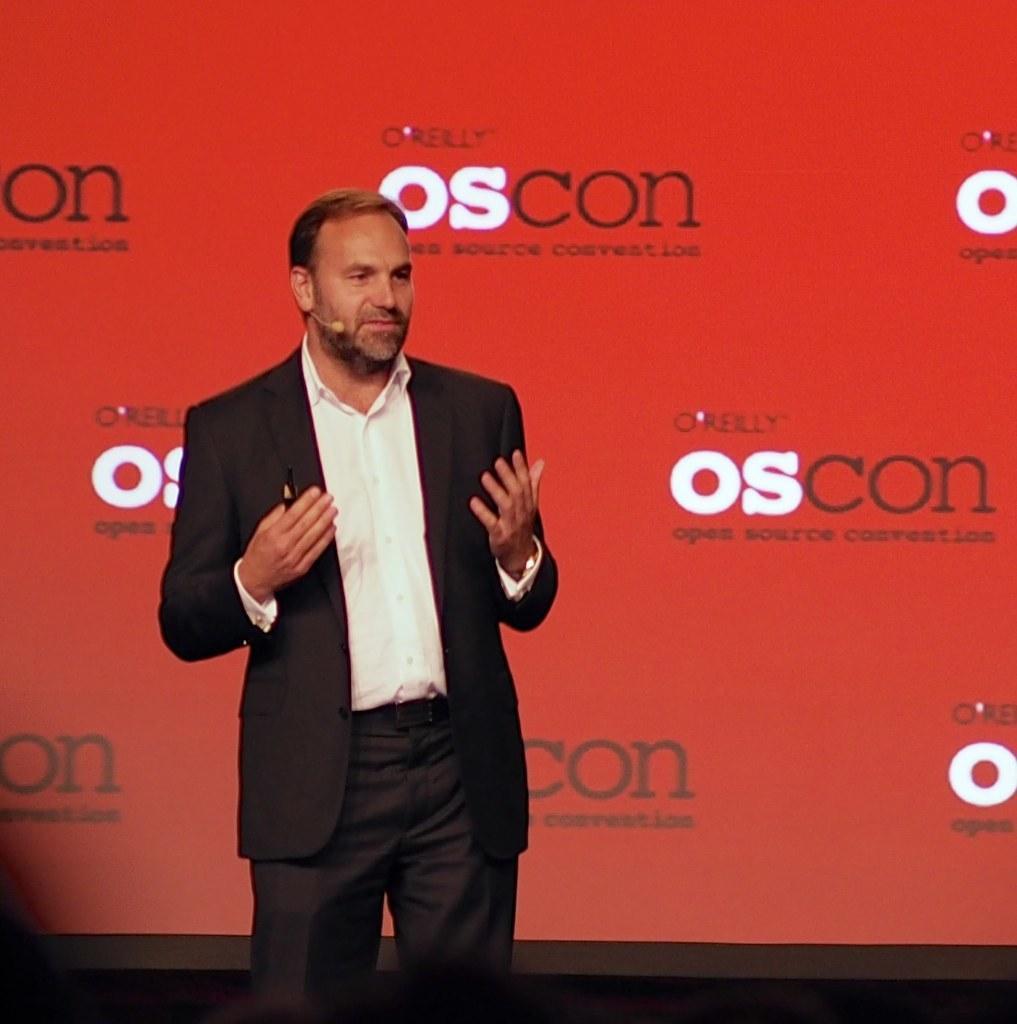Please provide a concise description of this image. In the image in the center we can see one person standing and holding some object. In the background there is a banner. 